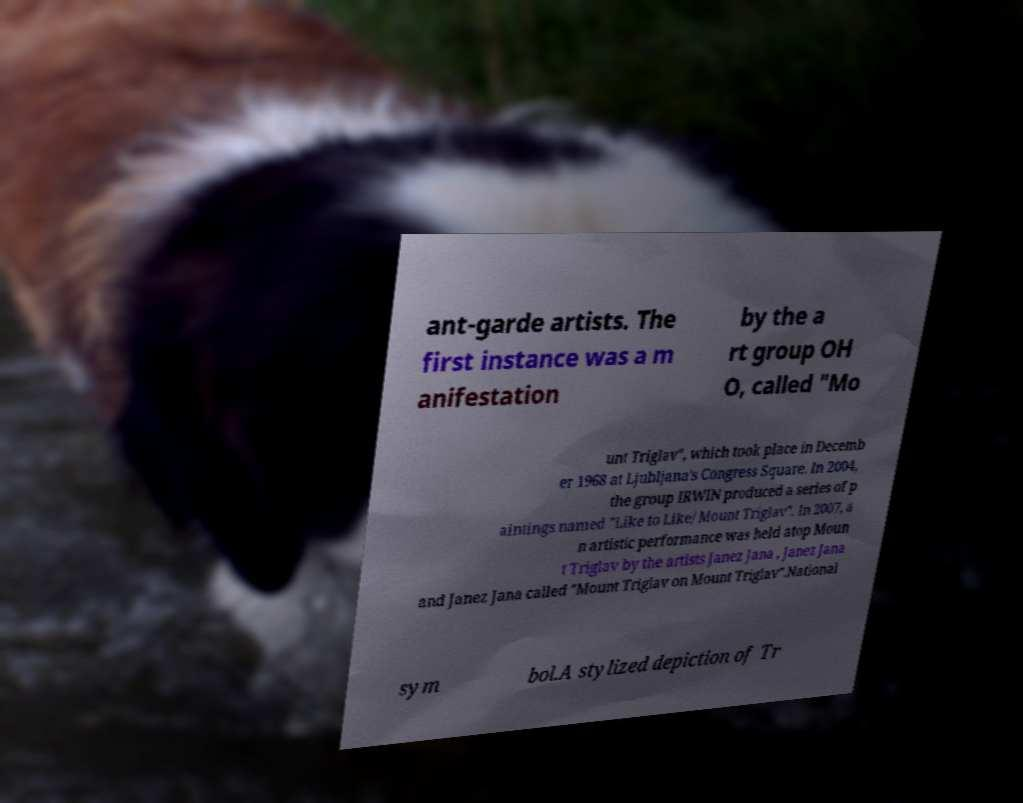Please identify and transcribe the text found in this image. ant-garde artists. The first instance was a m anifestation by the a rt group OH O, called "Mo unt Triglav", which took place in Decemb er 1968 at Ljubljana's Congress Square. In 2004, the group IRWIN produced a series of p aintings named "Like to Like/ Mount Triglav". In 2007, a n artistic performance was held atop Moun t Triglav by the artists Janez Jana , Janez Jana and Janez Jana called "Mount Triglav on Mount Triglav".National sym bol.A stylized depiction of Tr 